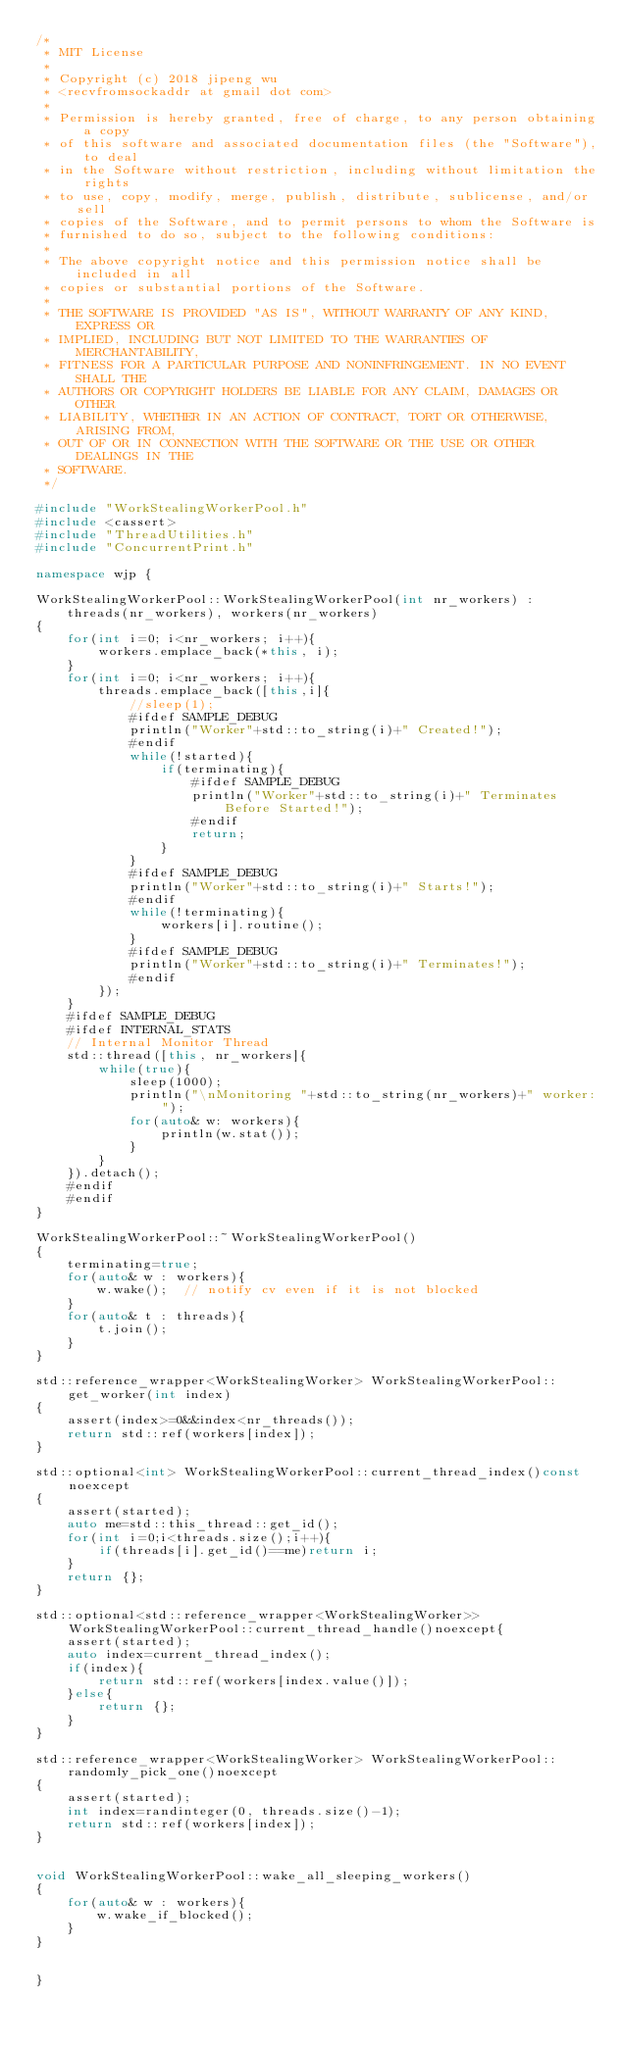<code> <loc_0><loc_0><loc_500><loc_500><_C++_>/*
 * MIT License
 *
 * Copyright (c) 2018 jipeng wu
 * <recvfromsockaddr at gmail dot com>
 *
 * Permission is hereby granted, free of charge, to any person obtaining a copy
 * of this software and associated documentation files (the "Software"), to deal
 * in the Software without restriction, including without limitation the rights
 * to use, copy, modify, merge, publish, distribute, sublicense, and/or sell
 * copies of the Software, and to permit persons to whom the Software is
 * furnished to do so, subject to the following conditions:
 *
 * The above copyright notice and this permission notice shall be included in all
 * copies or substantial portions of the Software.
 *
 * THE SOFTWARE IS PROVIDED "AS IS", WITHOUT WARRANTY OF ANY KIND, EXPRESS OR
 * IMPLIED, INCLUDING BUT NOT LIMITED TO THE WARRANTIES OF MERCHANTABILITY,
 * FITNESS FOR A PARTICULAR PURPOSE AND NONINFRINGEMENT. IN NO EVENT SHALL THE
 * AUTHORS OR COPYRIGHT HOLDERS BE LIABLE FOR ANY CLAIM, DAMAGES OR OTHER
 * LIABILITY, WHETHER IN AN ACTION OF CONTRACT, TORT OR OTHERWISE, ARISING FROM,
 * OUT OF OR IN CONNECTION WITH THE SOFTWARE OR THE USE OR OTHER DEALINGS IN THE
 * SOFTWARE.
 */

#include "WorkStealingWorkerPool.h"
#include <cassert>
#include "ThreadUtilities.h"
#include "ConcurrentPrint.h"

namespace wjp {

WorkStealingWorkerPool::WorkStealingWorkerPool(int nr_workers) :
    threads(nr_workers), workers(nr_workers)
{
    for(int i=0; i<nr_workers; i++){
        workers.emplace_back(*this, i);
    }
    for(int i=0; i<nr_workers; i++){
        threads.emplace_back([this,i]{
            //sleep(1);
            #ifdef SAMPLE_DEBUG
            println("Worker"+std::to_string(i)+" Created!");
            #endif
            while(!started){
                if(terminating){
                    #ifdef SAMPLE_DEBUG
                    println("Worker"+std::to_string(i)+" Terminates Before Started!");
                    #endif       
                    return;
                }
            }
            #ifdef SAMPLE_DEBUG
            println("Worker"+std::to_string(i)+" Starts!");
            #endif
            while(!terminating){
                workers[i].routine(); 
            }
            #ifdef SAMPLE_DEBUG
            println("Worker"+std::to_string(i)+" Terminates!");
            #endif
        });
    }
    #ifdef SAMPLE_DEBUG
    #ifdef INTERNAL_STATS
    // Internal Monitor Thread
    std::thread([this, nr_workers]{
        while(true){
            sleep(1000);
            println("\nMonitoring "+std::to_string(nr_workers)+" worker:");
            for(auto& w: workers){
                println(w.stat());
            }
        }
    }).detach();
    #endif
    #endif
}

WorkStealingWorkerPool::~WorkStealingWorkerPool() 
{
    terminating=true;  
    for(auto& w : workers){
        w.wake();  // notify cv even if it is not blocked
    }
    for(auto& t : threads){
        t.join(); 
    }
}

std::reference_wrapper<WorkStealingWorker> WorkStealingWorkerPool::get_worker(int index)
{
    assert(index>=0&&index<nr_threads());
    return std::ref(workers[index]);
}

std::optional<int> WorkStealingWorkerPool::current_thread_index()const noexcept
{
    assert(started);
    auto me=std::this_thread::get_id();
    for(int i=0;i<threads.size();i++){
        if(threads[i].get_id()==me)return i;
    }
    return {};
}

std::optional<std::reference_wrapper<WorkStealingWorker>> WorkStealingWorkerPool::current_thread_handle()noexcept{
    assert(started);
    auto index=current_thread_index();
    if(index){
        return std::ref(workers[index.value()]);
    }else{
        return {};
    }
}

std::reference_wrapper<WorkStealingWorker> WorkStealingWorkerPool::randomly_pick_one()noexcept
{
    assert(started);
    int index=randinteger(0, threads.size()-1);
    return std::ref(workers[index]);
}


void WorkStealingWorkerPool::wake_all_sleeping_workers()
{
    for(auto& w : workers){
        w.wake_if_blocked();
    }
}


}

</code> 